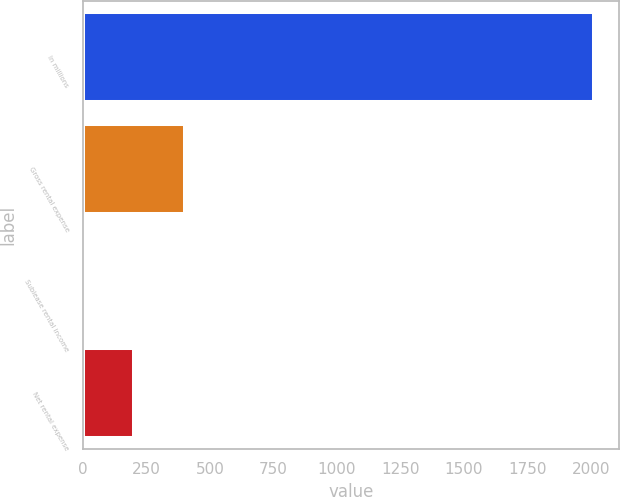Convert chart. <chart><loc_0><loc_0><loc_500><loc_500><bar_chart><fcel>In millions<fcel>Gross rental expense<fcel>Sublease rental income<fcel>Net rental expense<nl><fcel>2012<fcel>402.8<fcel>0.5<fcel>201.65<nl></chart> 